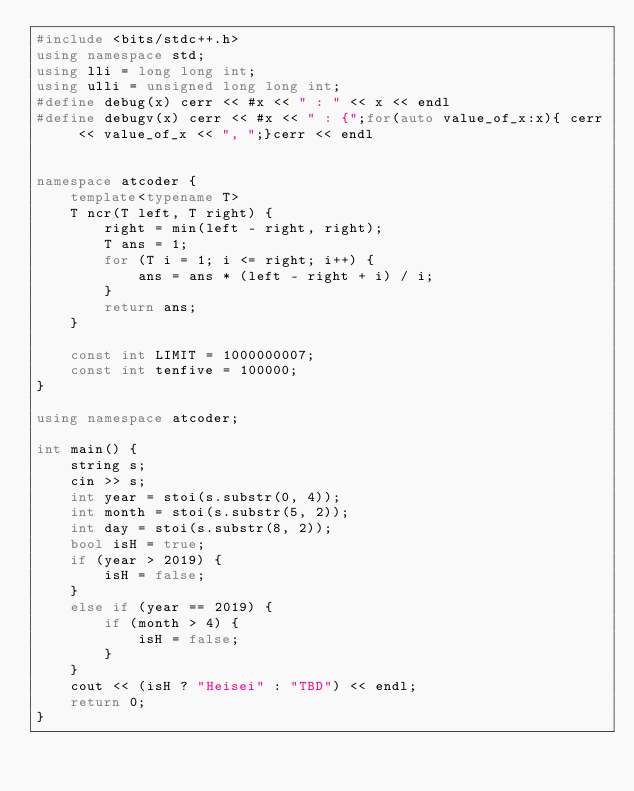Convert code to text. <code><loc_0><loc_0><loc_500><loc_500><_C++_>#include <bits/stdc++.h>
using namespace std;
using lli = long long int;
using ulli = unsigned long long int;
#define debug(x) cerr << #x << " : " << x << endl
#define debugv(x) cerr << #x << " : {";for(auto value_of_x:x){ cerr << value_of_x << ", ";}cerr << endl


namespace atcoder {
	template<typename T>
	T ncr(T left, T right) {
		right = min(left - right, right);
		T ans = 1;
		for (T i = 1; i <= right; i++) {
			ans = ans * (left - right + i) / i;
		}
		return ans;
	}

	const int LIMIT = 1000000007;
	const int tenfive = 100000;
}

using namespace atcoder;

int main() {
	string s;
	cin >> s;
	int year = stoi(s.substr(0, 4));
	int month = stoi(s.substr(5, 2));
	int day = stoi(s.substr(8, 2));
	bool isH = true;
	if (year > 2019) {
		isH = false;
	}
	else if (year == 2019) {
		if (month > 4) {
			isH = false;
		}
	}
	cout << (isH ? "Heisei" : "TBD") << endl;
	return 0;
}
</code> 